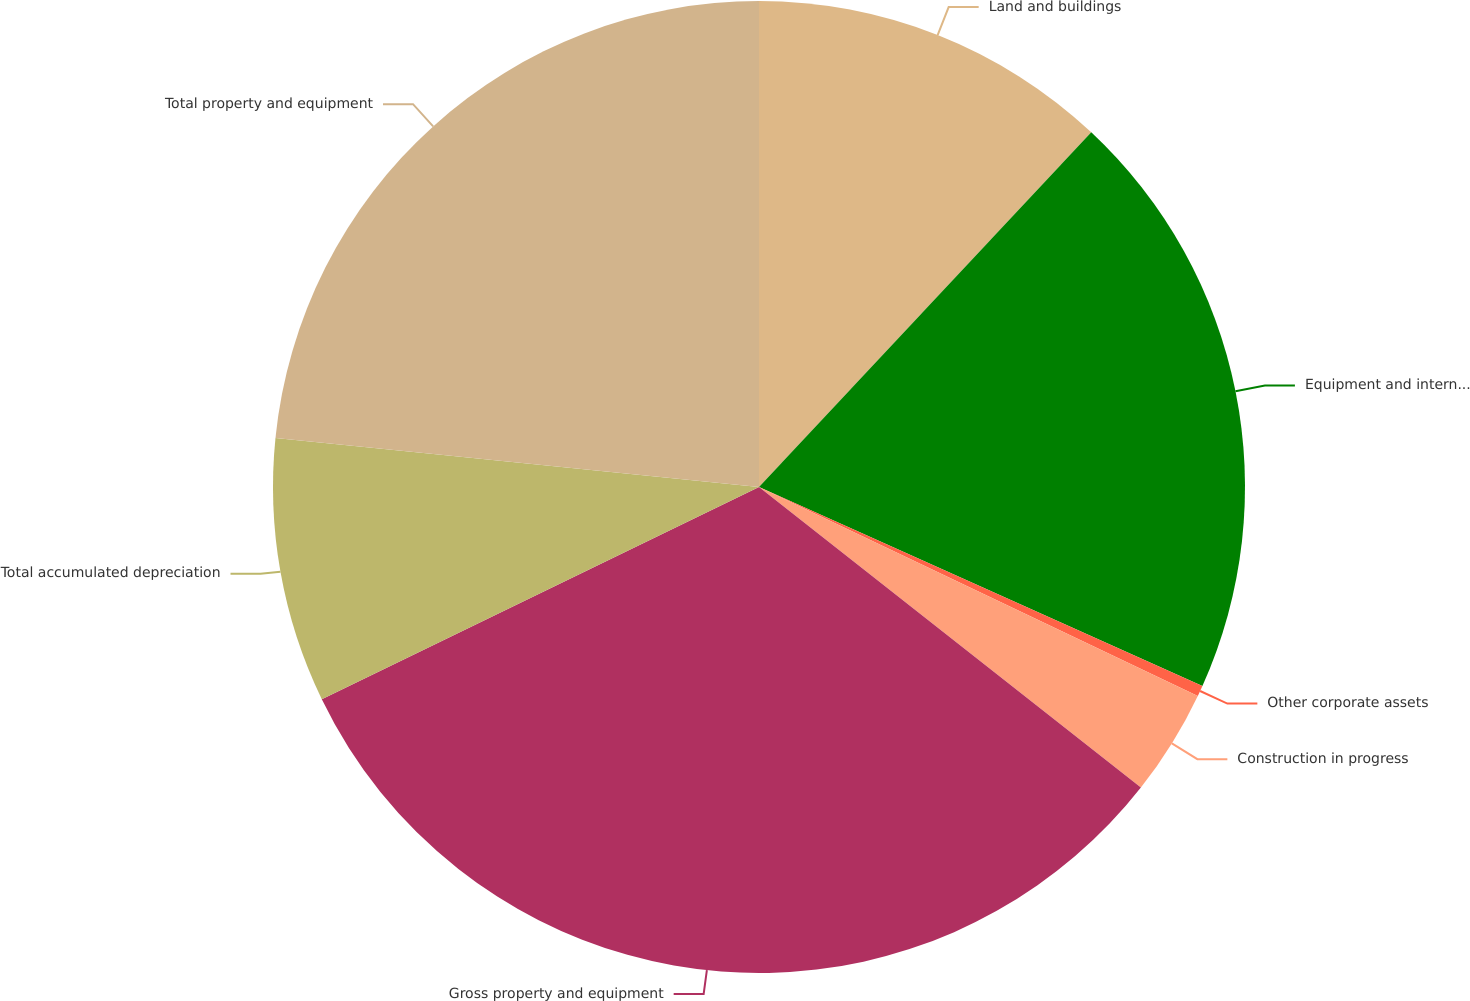Convert chart. <chart><loc_0><loc_0><loc_500><loc_500><pie_chart><fcel>Land and buildings<fcel>Equipment and internal-use<fcel>Other corporate assets<fcel>Construction in progress<fcel>Gross property and equipment<fcel>Total accumulated depreciation<fcel>Total property and equipment<nl><fcel>11.98%<fcel>19.73%<fcel>0.36%<fcel>3.54%<fcel>32.19%<fcel>8.8%<fcel>23.39%<nl></chart> 